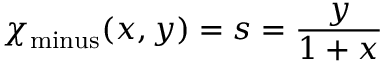<formula> <loc_0><loc_0><loc_500><loc_500>\chi _ { \min u s } ( x , y ) = s = { \frac { y } { 1 + x } }</formula> 